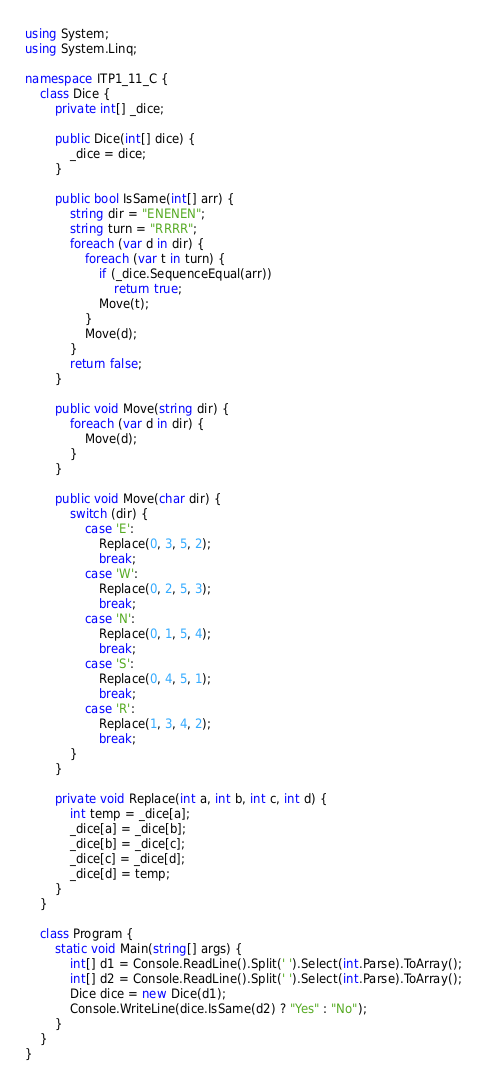<code> <loc_0><loc_0><loc_500><loc_500><_C#_>using System;
using System.Linq;

namespace ITP1_11_C {
    class Dice {
        private int[] _dice;
        
        public Dice(int[] dice) {
            _dice = dice;
        }

        public bool IsSame(int[] arr) {
            string dir = "ENENEN";
            string turn = "RRRR";
            foreach (var d in dir) {
                foreach (var t in turn) {
                    if (_dice.SequenceEqual(arr))
                        return true;
                    Move(t);
                }
                Move(d);
            }
            return false;
        }

        public void Move(string dir) {
            foreach (var d in dir) {
                Move(d);
            }
        }

        public void Move(char dir) {
            switch (dir) {
                case 'E':
                    Replace(0, 3, 5, 2);
                    break;
                case 'W':
                    Replace(0, 2, 5, 3);
                    break;
                case 'N':
                    Replace(0, 1, 5, 4);
                    break;
                case 'S':
                    Replace(0, 4, 5, 1);
                    break;
                case 'R':
                    Replace(1, 3, 4, 2);
                    break;
            }
        }

        private void Replace(int a, int b, int c, int d) {
            int temp = _dice[a];
            _dice[a] = _dice[b];
            _dice[b] = _dice[c];
            _dice[c] = _dice[d];
            _dice[d] = temp;
        }
    }

    class Program {
        static void Main(string[] args) {
            int[] d1 = Console.ReadLine().Split(' ').Select(int.Parse).ToArray();
            int[] d2 = Console.ReadLine().Split(' ').Select(int.Parse).ToArray();
            Dice dice = new Dice(d1);
            Console.WriteLine(dice.IsSame(d2) ? "Yes" : "No");
        }
    }
}</code> 